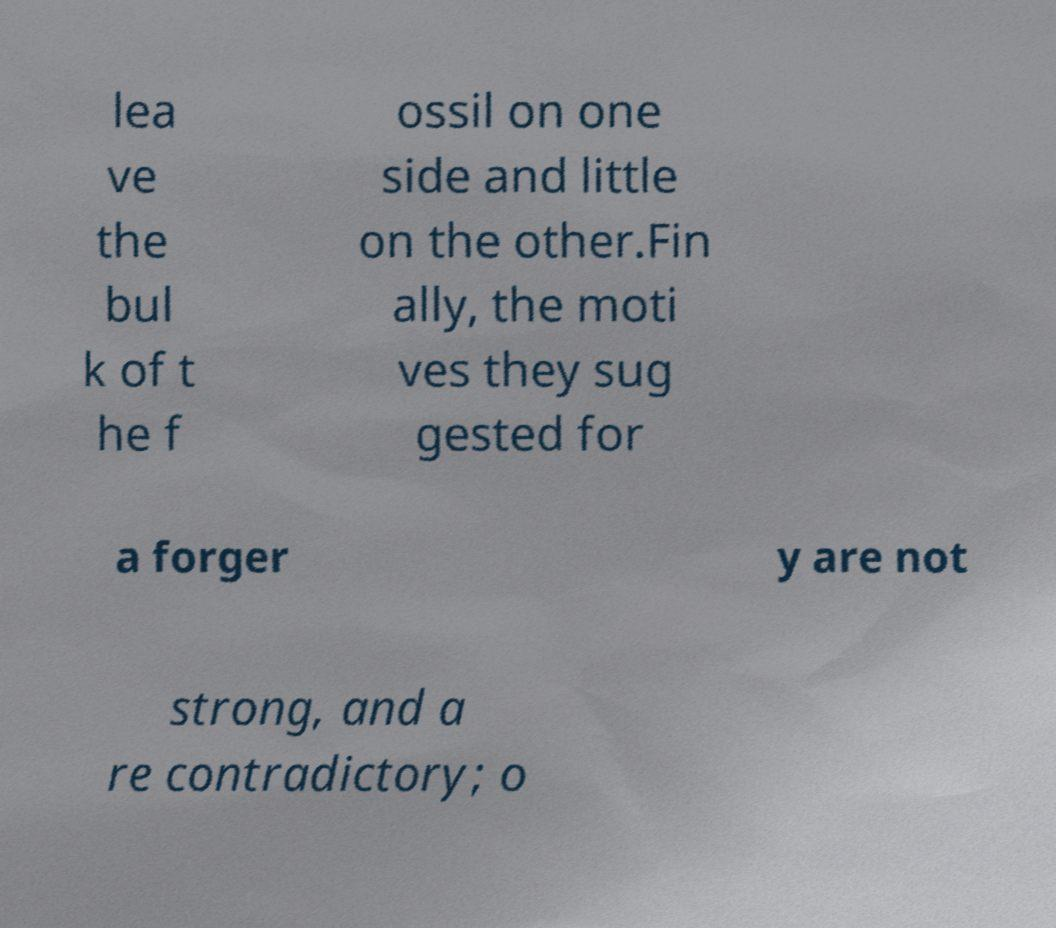I need the written content from this picture converted into text. Can you do that? lea ve the bul k of t he f ossil on one side and little on the other.Fin ally, the moti ves they sug gested for a forger y are not strong, and a re contradictory; o 